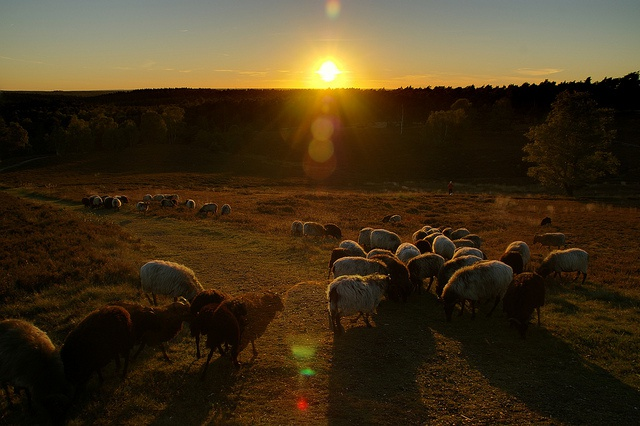Describe the objects in this image and their specific colors. I can see sheep in gray, black, maroon, and olive tones, sheep in black, maroon, and gray tones, sheep in gray, black, maroon, and olive tones, sheep in gray, black, maroon, and olive tones, and sheep in gray, black, maroon, and olive tones in this image. 